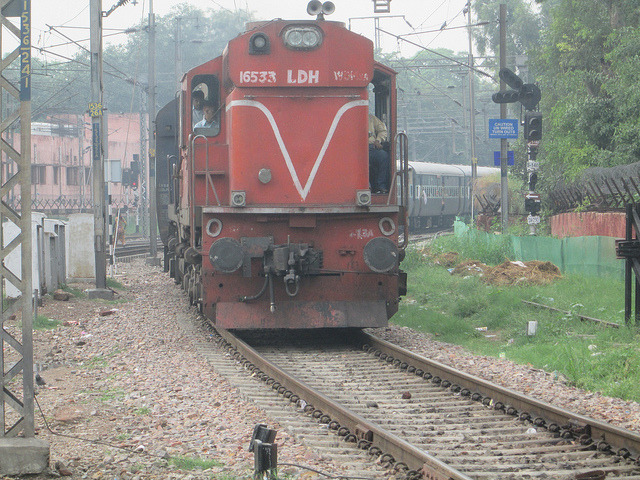Read all the text in this image. 1536241 16553 LDH 